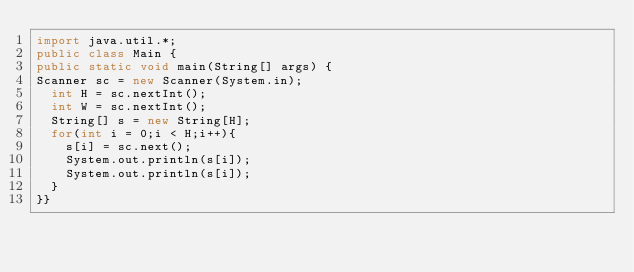Convert code to text. <code><loc_0><loc_0><loc_500><loc_500><_Java_>import java.util.*;
public class Main {
public static void main(String[] args) {
Scanner sc = new Scanner(System.in);
  int H = sc.nextInt();
  int W = sc.nextInt();
  String[] s = new String[H];
  for(int i = 0;i < H;i++){
    s[i] = sc.next();
    System.out.println(s[i]);
    System.out.println(s[i]);
  }
}}</code> 